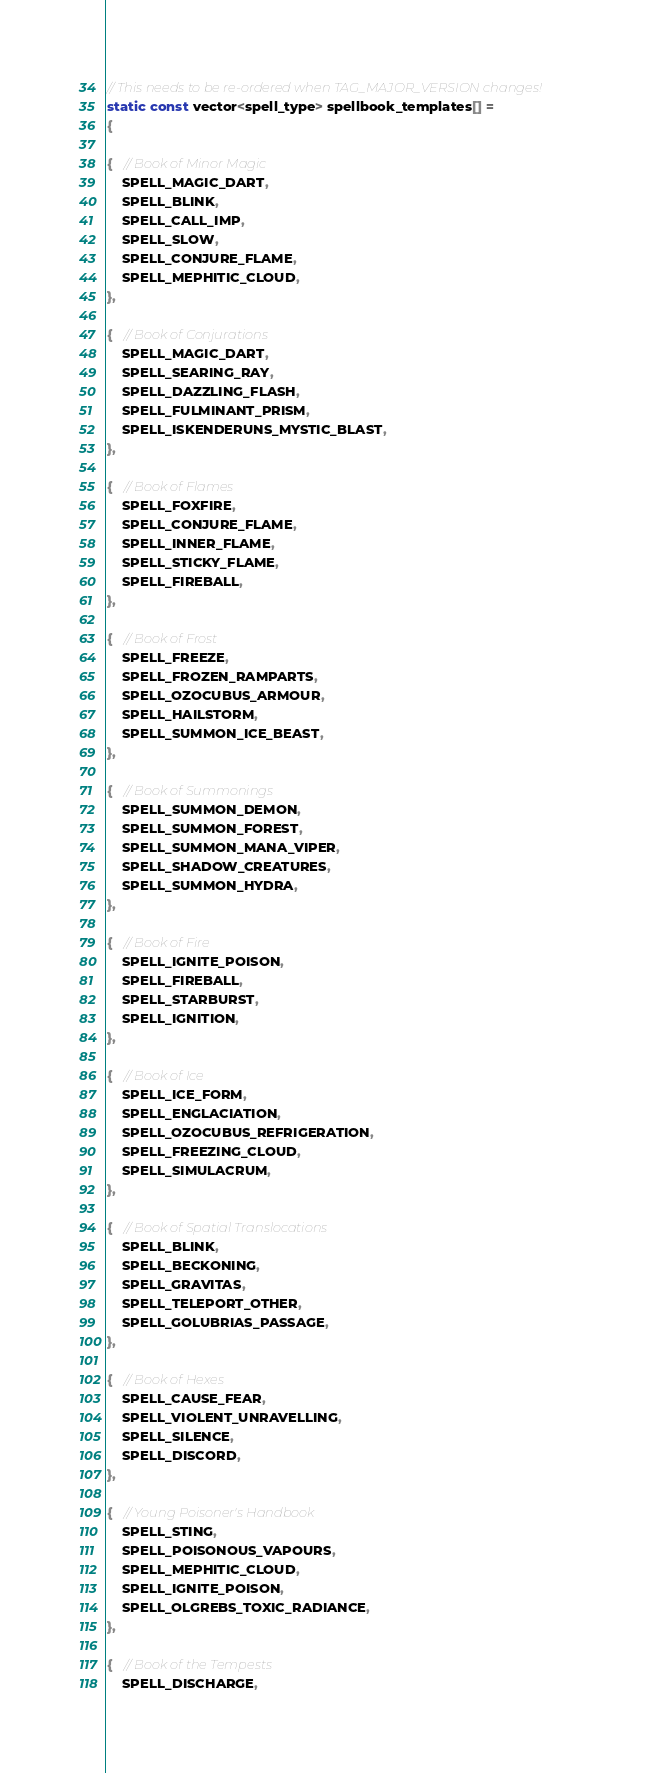<code> <loc_0><loc_0><loc_500><loc_500><_C_>// This needs to be re-ordered when TAG_MAJOR_VERSION changes!
static const vector<spell_type> spellbook_templates[] =
{

{   // Book of Minor Magic
    SPELL_MAGIC_DART,
    SPELL_BLINK,
    SPELL_CALL_IMP,
    SPELL_SLOW,
    SPELL_CONJURE_FLAME,
    SPELL_MEPHITIC_CLOUD,
},

{   // Book of Conjurations
    SPELL_MAGIC_DART,
    SPELL_SEARING_RAY,
    SPELL_DAZZLING_FLASH,
    SPELL_FULMINANT_PRISM,
    SPELL_ISKENDERUNS_MYSTIC_BLAST,
},

{   // Book of Flames
    SPELL_FOXFIRE,
    SPELL_CONJURE_FLAME,
    SPELL_INNER_FLAME,
    SPELL_STICKY_FLAME,
    SPELL_FIREBALL,
},

{   // Book of Frost
    SPELL_FREEZE,
    SPELL_FROZEN_RAMPARTS,
    SPELL_OZOCUBUS_ARMOUR,
    SPELL_HAILSTORM,
    SPELL_SUMMON_ICE_BEAST,
},

{   // Book of Summonings
    SPELL_SUMMON_DEMON,
    SPELL_SUMMON_FOREST,
    SPELL_SUMMON_MANA_VIPER,
    SPELL_SHADOW_CREATURES,
    SPELL_SUMMON_HYDRA,
},

{   // Book of Fire
    SPELL_IGNITE_POISON,
    SPELL_FIREBALL,
    SPELL_STARBURST,
    SPELL_IGNITION,
},

{   // Book of Ice
    SPELL_ICE_FORM,
    SPELL_ENGLACIATION,
    SPELL_OZOCUBUS_REFRIGERATION,
    SPELL_FREEZING_CLOUD,
    SPELL_SIMULACRUM,
},

{   // Book of Spatial Translocations
    SPELL_BLINK,
    SPELL_BECKONING,
    SPELL_GRAVITAS,
    SPELL_TELEPORT_OTHER,
    SPELL_GOLUBRIAS_PASSAGE,
},

{   // Book of Hexes
    SPELL_CAUSE_FEAR,
    SPELL_VIOLENT_UNRAVELLING,
    SPELL_SILENCE,
    SPELL_DISCORD,
},

{   // Young Poisoner's Handbook
    SPELL_STING,
    SPELL_POISONOUS_VAPOURS,
    SPELL_MEPHITIC_CLOUD,
    SPELL_IGNITE_POISON,
    SPELL_OLGREBS_TOXIC_RADIANCE,
},

{   // Book of the Tempests
    SPELL_DISCHARGE,</code> 